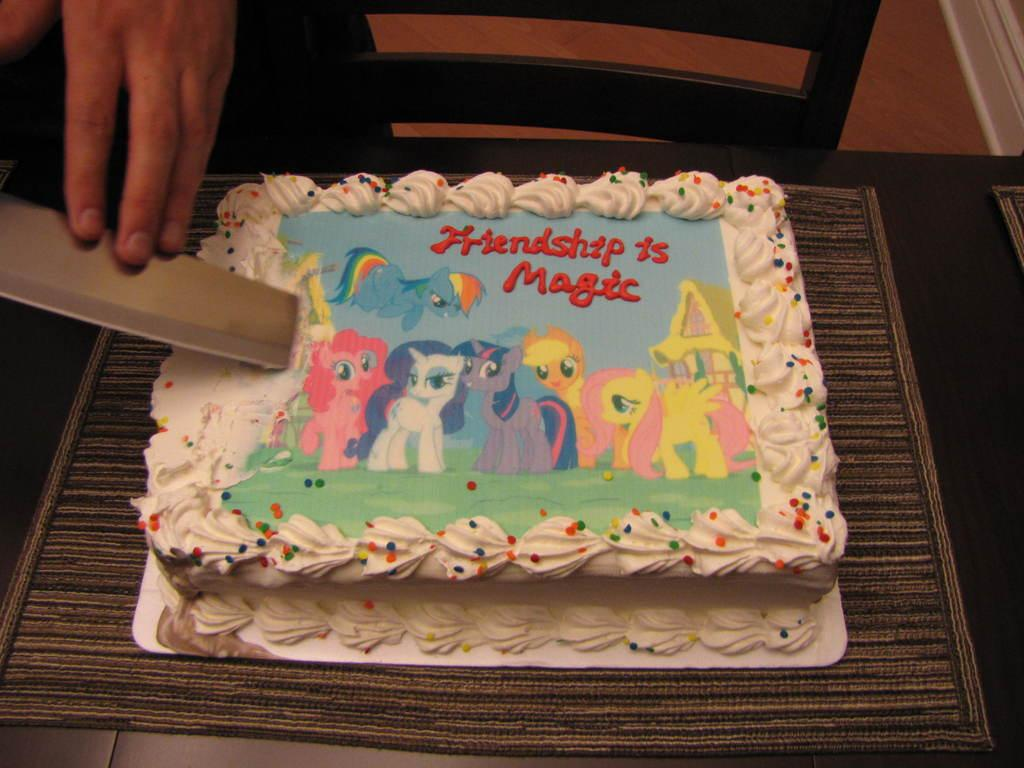What body part is visible in the image? There are hands visible in the image. What is the person holding in the image? The person is holding an object. What type of food is on the table in the image? There is a cake on a table in the image. What piece of furniture is present in the image? A chair is present in the image. What surface can be seen beneath the table in the image? The floor is visible in the image. How many clocks are visible on the wall in the image? There are no clocks visible on the wall in the image. What type of wind can be felt in the image? There is no mention of wind in the image, so it cannot be determined if any type of wind is present. 